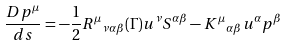<formula> <loc_0><loc_0><loc_500><loc_500>\frac { D p ^ { \mu } } { d s } = - \frac { 1 } { 2 } { { R ^ { \mu } } _ { { \nu } { \alpha } { \beta } } } ( \Gamma ) u ^ { \nu } S ^ { { \alpha } { \beta } } - { K ^ { \mu } } _ { { \alpha } { \beta } } u ^ { \alpha } p ^ { \beta }</formula> 